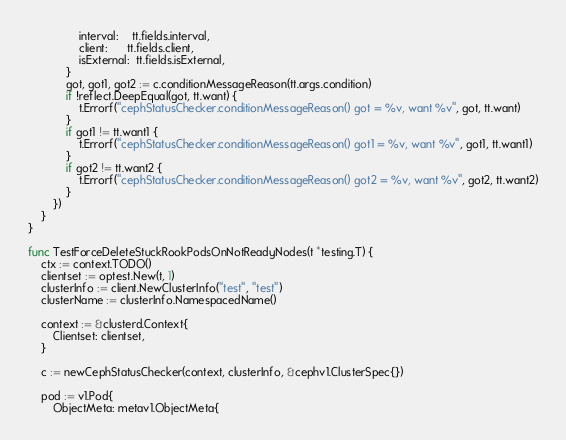Convert code to text. <code><loc_0><loc_0><loc_500><loc_500><_Go_>				interval:    tt.fields.interval,
				client:      tt.fields.client,
				isExternal:  tt.fields.isExternal,
			}
			got, got1, got2 := c.conditionMessageReason(tt.args.condition)
			if !reflect.DeepEqual(got, tt.want) {
				t.Errorf("cephStatusChecker.conditionMessageReason() got = %v, want %v", got, tt.want)
			}
			if got1 != tt.want1 {
				t.Errorf("cephStatusChecker.conditionMessageReason() got1 = %v, want %v", got1, tt.want1)
			}
			if got2 != tt.want2 {
				t.Errorf("cephStatusChecker.conditionMessageReason() got2 = %v, want %v", got2, tt.want2)
			}
		})
	}
}

func TestForceDeleteStuckRookPodsOnNotReadyNodes(t *testing.T) {
	ctx := context.TODO()
	clientset := optest.New(t, 1)
	clusterInfo := client.NewClusterInfo("test", "test")
	clusterName := clusterInfo.NamespacedName()

	context := &clusterd.Context{
		Clientset: clientset,
	}

	c := newCephStatusChecker(context, clusterInfo, &cephv1.ClusterSpec{})

	pod := v1.Pod{
		ObjectMeta: metav1.ObjectMeta{</code> 